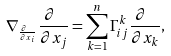<formula> <loc_0><loc_0><loc_500><loc_500>\nabla _ { \frac { \partial \ } { \partial x _ { i } } } \frac { \partial \ } { \partial x _ { j } } = \sum _ { k = 1 } ^ { n } \Gamma _ { i j } ^ { k } \frac { \partial \ } { \partial x _ { k } } ,</formula> 